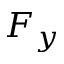<formula> <loc_0><loc_0><loc_500><loc_500>F _ { y }</formula> 